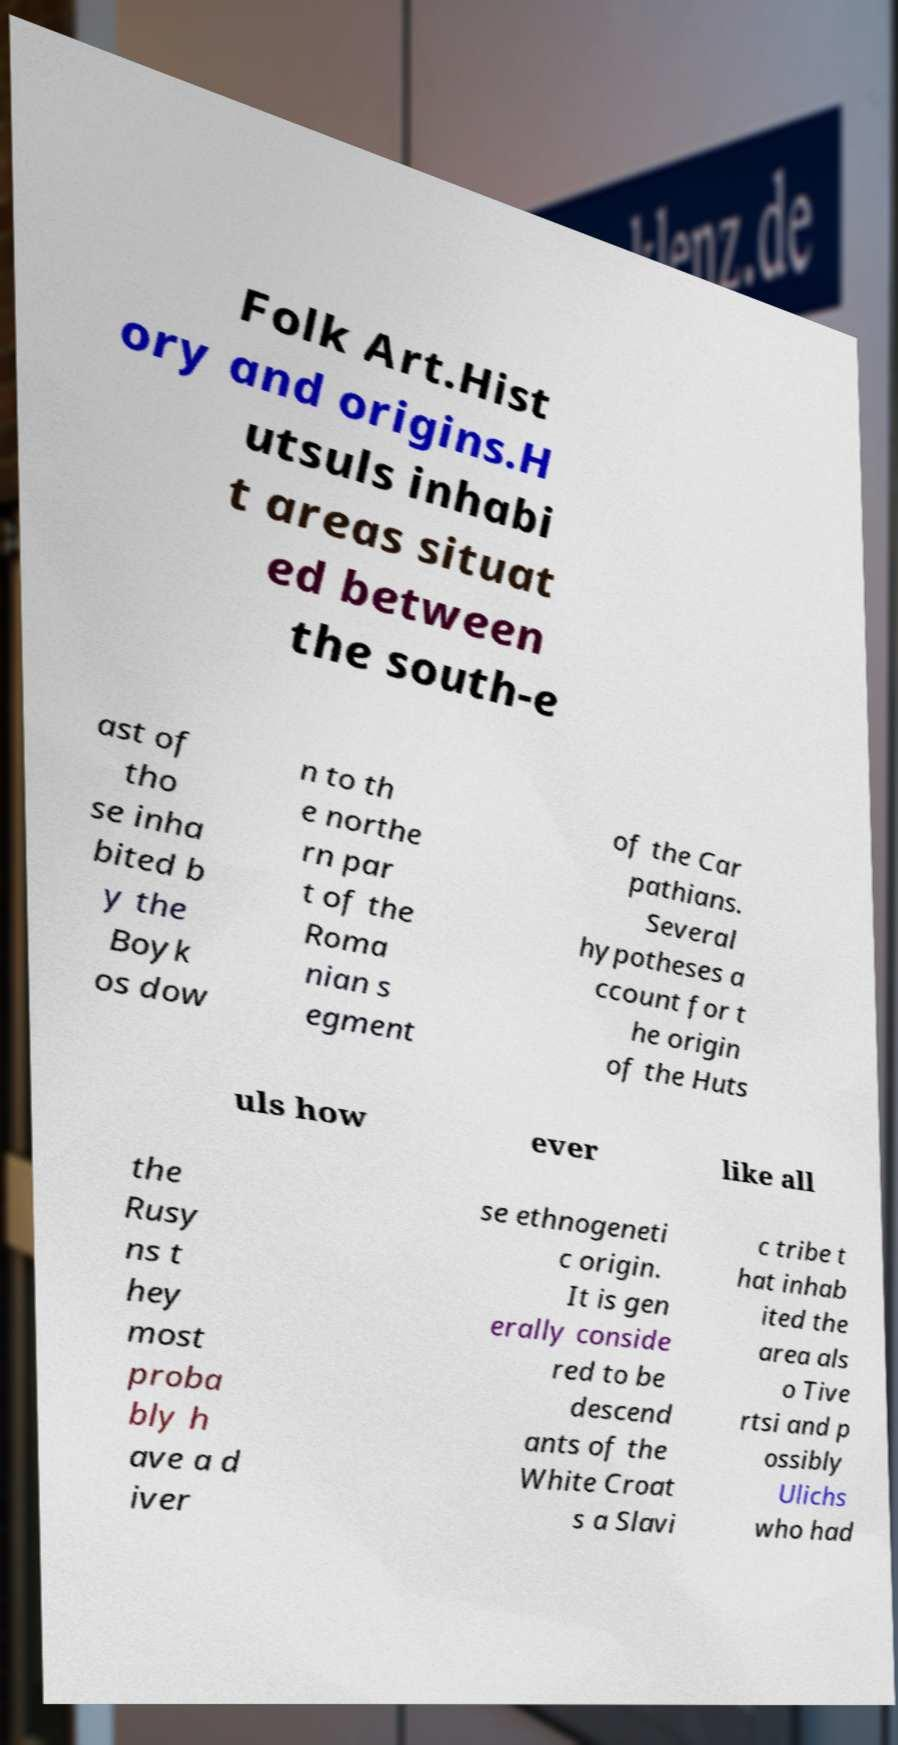I need the written content from this picture converted into text. Can you do that? Folk Art.Hist ory and origins.H utsuls inhabi t areas situat ed between the south-e ast of tho se inha bited b y the Boyk os dow n to th e northe rn par t of the Roma nian s egment of the Car pathians. Several hypotheses a ccount for t he origin of the Huts uls how ever like all the Rusy ns t hey most proba bly h ave a d iver se ethnogeneti c origin. It is gen erally conside red to be descend ants of the White Croat s a Slavi c tribe t hat inhab ited the area als o Tive rtsi and p ossibly Ulichs who had 